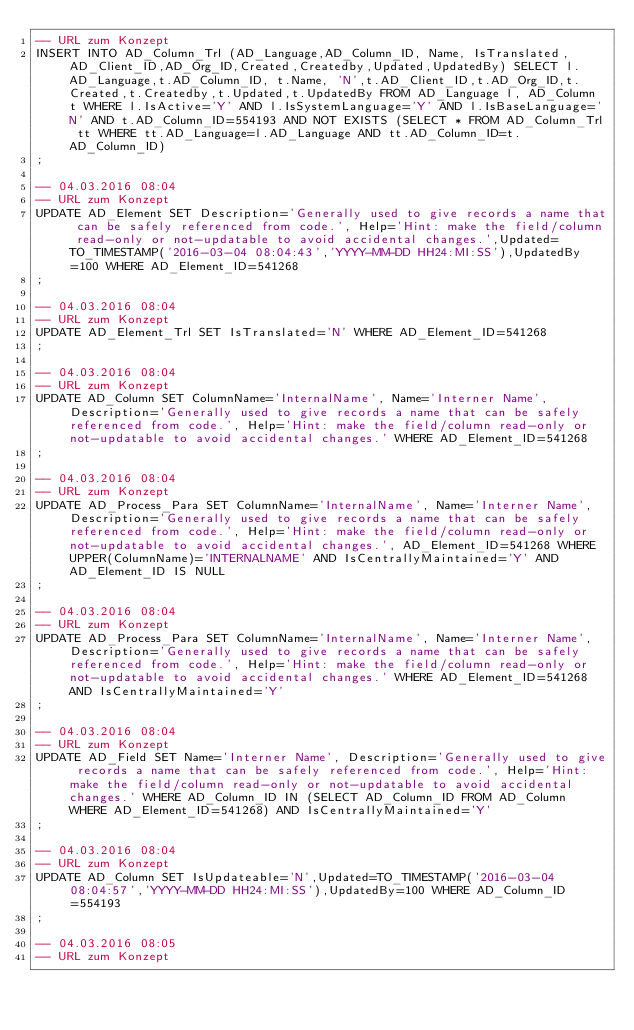Convert code to text. <code><loc_0><loc_0><loc_500><loc_500><_SQL_>-- URL zum Konzept
INSERT INTO AD_Column_Trl (AD_Language,AD_Column_ID, Name, IsTranslated,AD_Client_ID,AD_Org_ID,Created,Createdby,Updated,UpdatedBy) SELECT l.AD_Language,t.AD_Column_ID, t.Name, 'N',t.AD_Client_ID,t.AD_Org_ID,t.Created,t.Createdby,t.Updated,t.UpdatedBy FROM AD_Language l, AD_Column t WHERE l.IsActive='Y' AND l.IsSystemLanguage='Y' AND l.IsBaseLanguage='N' AND t.AD_Column_ID=554193 AND NOT EXISTS (SELECT * FROM AD_Column_Trl tt WHERE tt.AD_Language=l.AD_Language AND tt.AD_Column_ID=t.AD_Column_ID)
;

-- 04.03.2016 08:04
-- URL zum Konzept
UPDATE AD_Element SET Description='Generally used to give records a name that can be safely referenced from code.', Help='Hint: make the field/column read-only or not-updatable to avoid accidental changes.',Updated=TO_TIMESTAMP('2016-03-04 08:04:43','YYYY-MM-DD HH24:MI:SS'),UpdatedBy=100 WHERE AD_Element_ID=541268
;

-- 04.03.2016 08:04
-- URL zum Konzept
UPDATE AD_Element_Trl SET IsTranslated='N' WHERE AD_Element_ID=541268
;

-- 04.03.2016 08:04
-- URL zum Konzept
UPDATE AD_Column SET ColumnName='InternalName', Name='Interner Name', Description='Generally used to give records a name that can be safely referenced from code.', Help='Hint: make the field/column read-only or not-updatable to avoid accidental changes.' WHERE AD_Element_ID=541268
;

-- 04.03.2016 08:04
-- URL zum Konzept
UPDATE AD_Process_Para SET ColumnName='InternalName', Name='Interner Name', Description='Generally used to give records a name that can be safely referenced from code.', Help='Hint: make the field/column read-only or not-updatable to avoid accidental changes.', AD_Element_ID=541268 WHERE UPPER(ColumnName)='INTERNALNAME' AND IsCentrallyMaintained='Y' AND AD_Element_ID IS NULL
;

-- 04.03.2016 08:04
-- URL zum Konzept
UPDATE AD_Process_Para SET ColumnName='InternalName', Name='Interner Name', Description='Generally used to give records a name that can be safely referenced from code.', Help='Hint: make the field/column read-only or not-updatable to avoid accidental changes.' WHERE AD_Element_ID=541268 AND IsCentrallyMaintained='Y'
;

-- 04.03.2016 08:04
-- URL zum Konzept
UPDATE AD_Field SET Name='Interner Name', Description='Generally used to give records a name that can be safely referenced from code.', Help='Hint: make the field/column read-only or not-updatable to avoid accidental changes.' WHERE AD_Column_ID IN (SELECT AD_Column_ID FROM AD_Column WHERE AD_Element_ID=541268) AND IsCentrallyMaintained='Y'
;

-- 04.03.2016 08:04
-- URL zum Konzept
UPDATE AD_Column SET IsUpdateable='N',Updated=TO_TIMESTAMP('2016-03-04 08:04:57','YYYY-MM-DD HH24:MI:SS'),UpdatedBy=100 WHERE AD_Column_ID=554193
;

-- 04.03.2016 08:05
-- URL zum Konzept</code> 